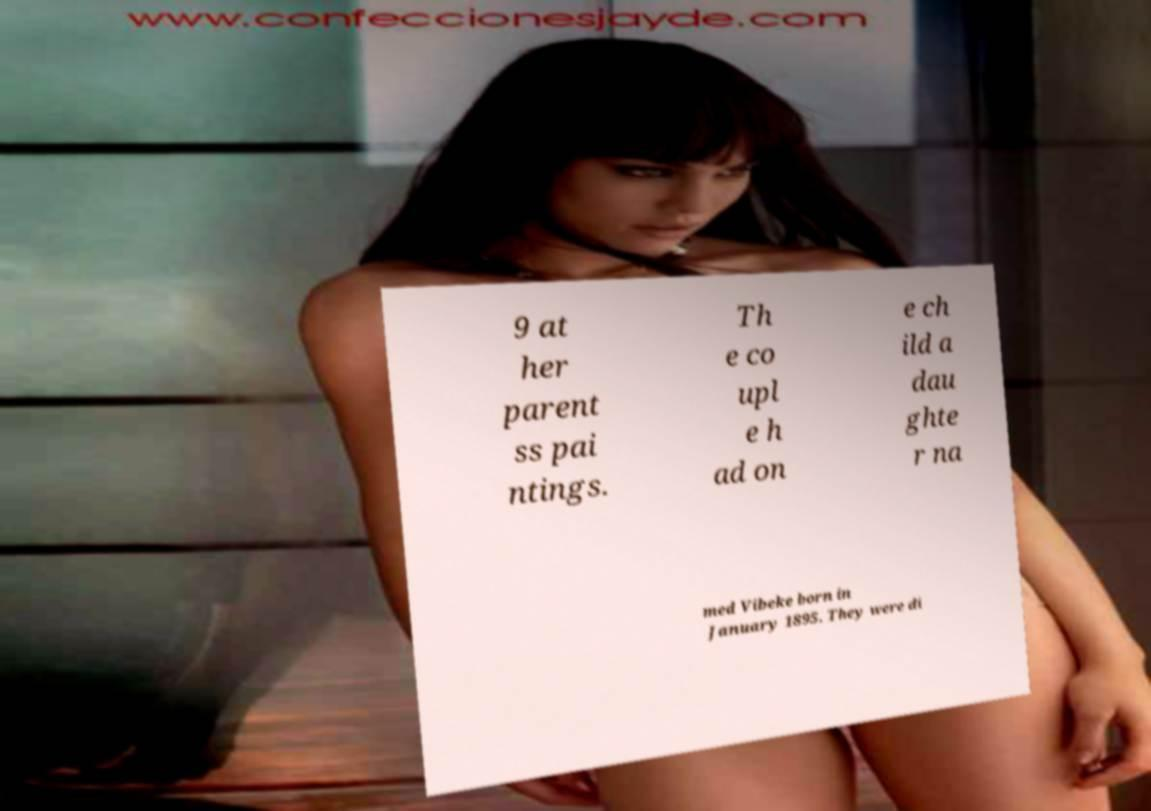What messages or text are displayed in this image? I need them in a readable, typed format. 9 at her parent ss pai ntings. Th e co upl e h ad on e ch ild a dau ghte r na med Vibeke born in January 1895. They were di 